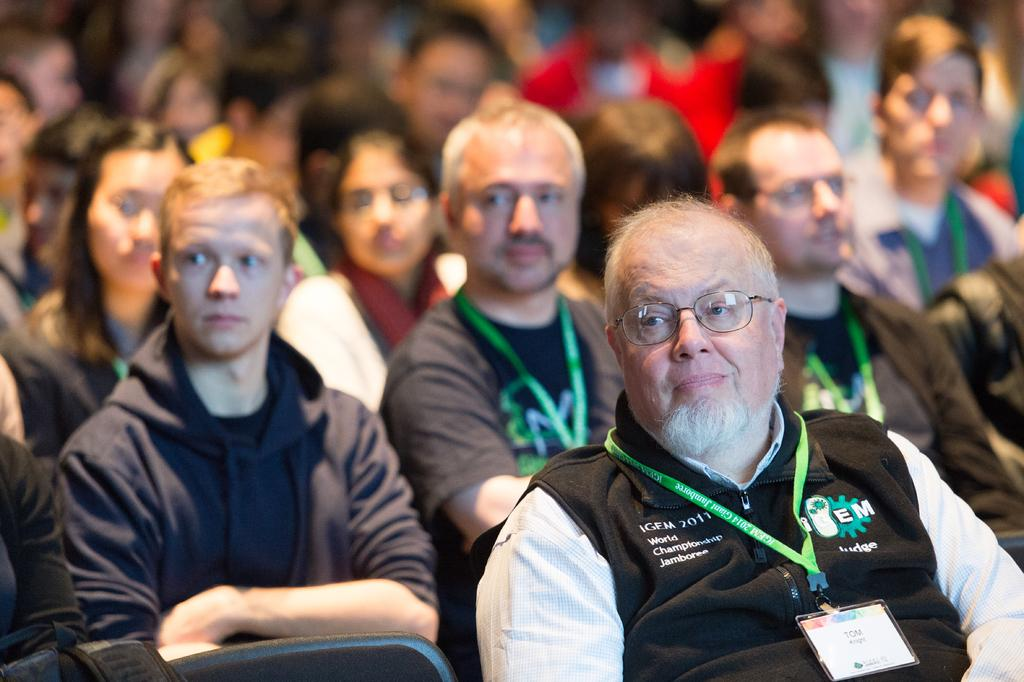What is the general setting of the image? The image shows many people sitting. Are there any distinguishing features among the people? Some of the people are wearing green tags. Can you describe the person in the front of the image? The person in the front is wearing glasses (specs). How many kittens are sitting on the person's lap in the image? There are no kittens present in the image. What type of apples are being served to the people in the image? There is no mention of apples or any food being served in the image. 